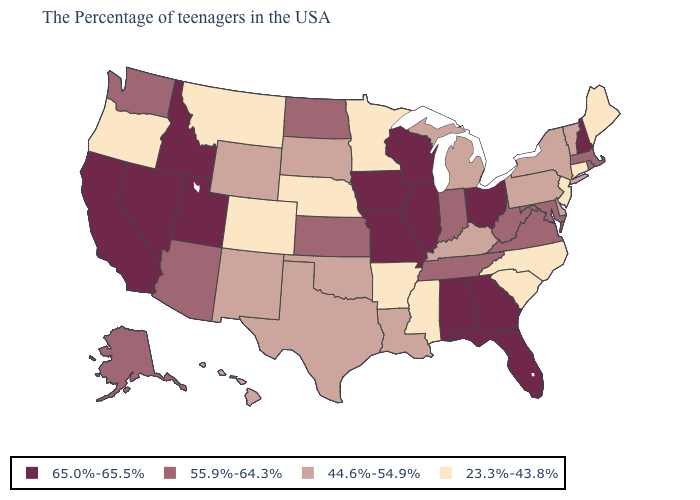Does the map have missing data?
Give a very brief answer. No. What is the lowest value in the USA?
Short answer required. 23.3%-43.8%. Name the states that have a value in the range 23.3%-43.8%?
Keep it brief. Maine, Connecticut, New Jersey, North Carolina, South Carolina, Mississippi, Arkansas, Minnesota, Nebraska, Colorado, Montana, Oregon. Among the states that border Rhode Island , which have the lowest value?
Quick response, please. Connecticut. What is the highest value in the South ?
Short answer required. 65.0%-65.5%. Name the states that have a value in the range 23.3%-43.8%?
Concise answer only. Maine, Connecticut, New Jersey, North Carolina, South Carolina, Mississippi, Arkansas, Minnesota, Nebraska, Colorado, Montana, Oregon. What is the value of Georgia?
Write a very short answer. 65.0%-65.5%. Which states hav the highest value in the MidWest?
Write a very short answer. Ohio, Wisconsin, Illinois, Missouri, Iowa. Name the states that have a value in the range 65.0%-65.5%?
Keep it brief. New Hampshire, Ohio, Florida, Georgia, Alabama, Wisconsin, Illinois, Missouri, Iowa, Utah, Idaho, Nevada, California. What is the value of Colorado?
Short answer required. 23.3%-43.8%. How many symbols are there in the legend?
Short answer required. 4. What is the value of Minnesota?
Be succinct. 23.3%-43.8%. Name the states that have a value in the range 44.6%-54.9%?
Concise answer only. Vermont, New York, Delaware, Pennsylvania, Michigan, Kentucky, Louisiana, Oklahoma, Texas, South Dakota, Wyoming, New Mexico, Hawaii. Name the states that have a value in the range 44.6%-54.9%?
Short answer required. Vermont, New York, Delaware, Pennsylvania, Michigan, Kentucky, Louisiana, Oklahoma, Texas, South Dakota, Wyoming, New Mexico, Hawaii. Does Illinois have the highest value in the USA?
Give a very brief answer. Yes. 